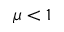Convert formula to latex. <formula><loc_0><loc_0><loc_500><loc_500>\mu < 1</formula> 